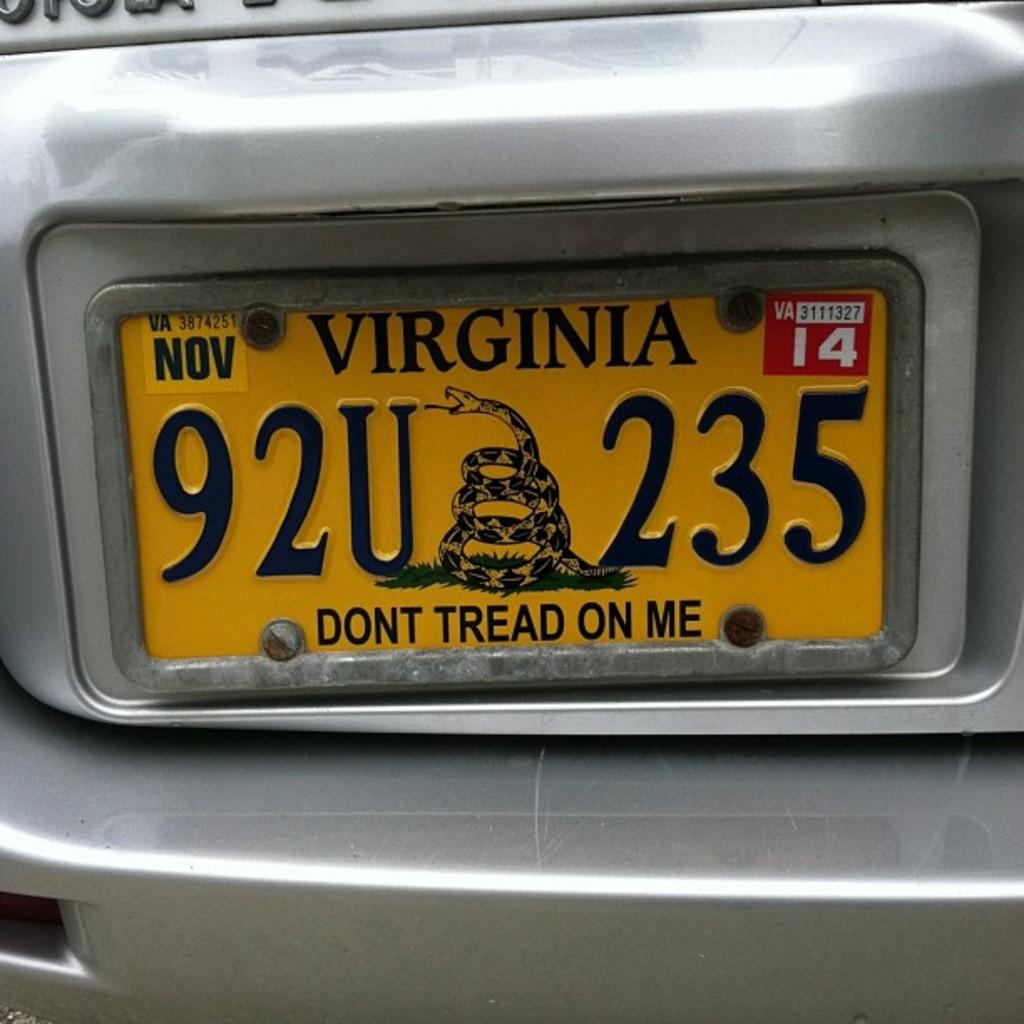<image>
Provide a brief description of the given image. A silver colored car from Virginia says "Don't Tread on Me". 